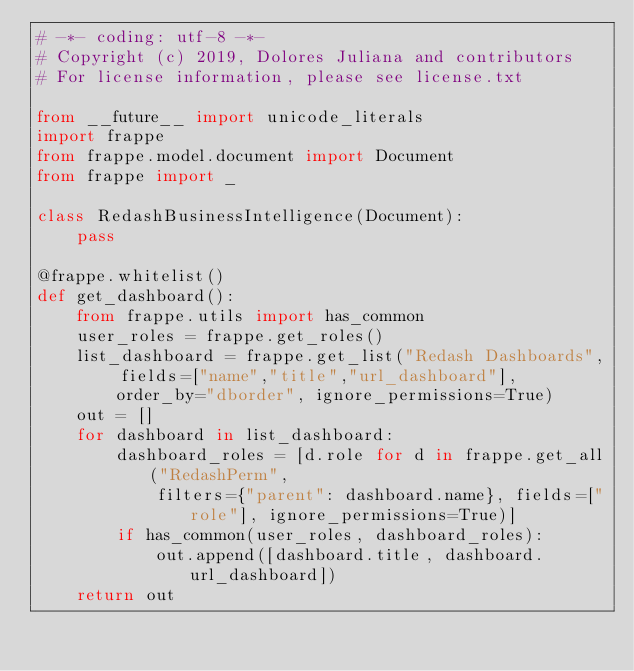<code> <loc_0><loc_0><loc_500><loc_500><_Python_># -*- coding: utf-8 -*-
# Copyright (c) 2019, Dolores Juliana and contributors
# For license information, please see license.txt

from __future__ import unicode_literals
import frappe
from frappe.model.document import Document
from frappe import _

class RedashBusinessIntelligence(Document):
	pass

@frappe.whitelist()
def get_dashboard():
	from frappe.utils import has_common
	user_roles = frappe.get_roles()
	list_dashboard = frappe.get_list("Redash Dashboards", fields=["name","title","url_dashboard"], 
		order_by="dborder", ignore_permissions=True)
	out = []
	for dashboard in list_dashboard:
		dashboard_roles = [d.role for d in frappe.get_all("RedashPerm", 
			filters={"parent": dashboard.name}, fields=["role"], ignore_permissions=True)]
		if has_common(user_roles, dashboard_roles):
			out.append([dashboard.title, dashboard.url_dashboard])
	return out
</code> 